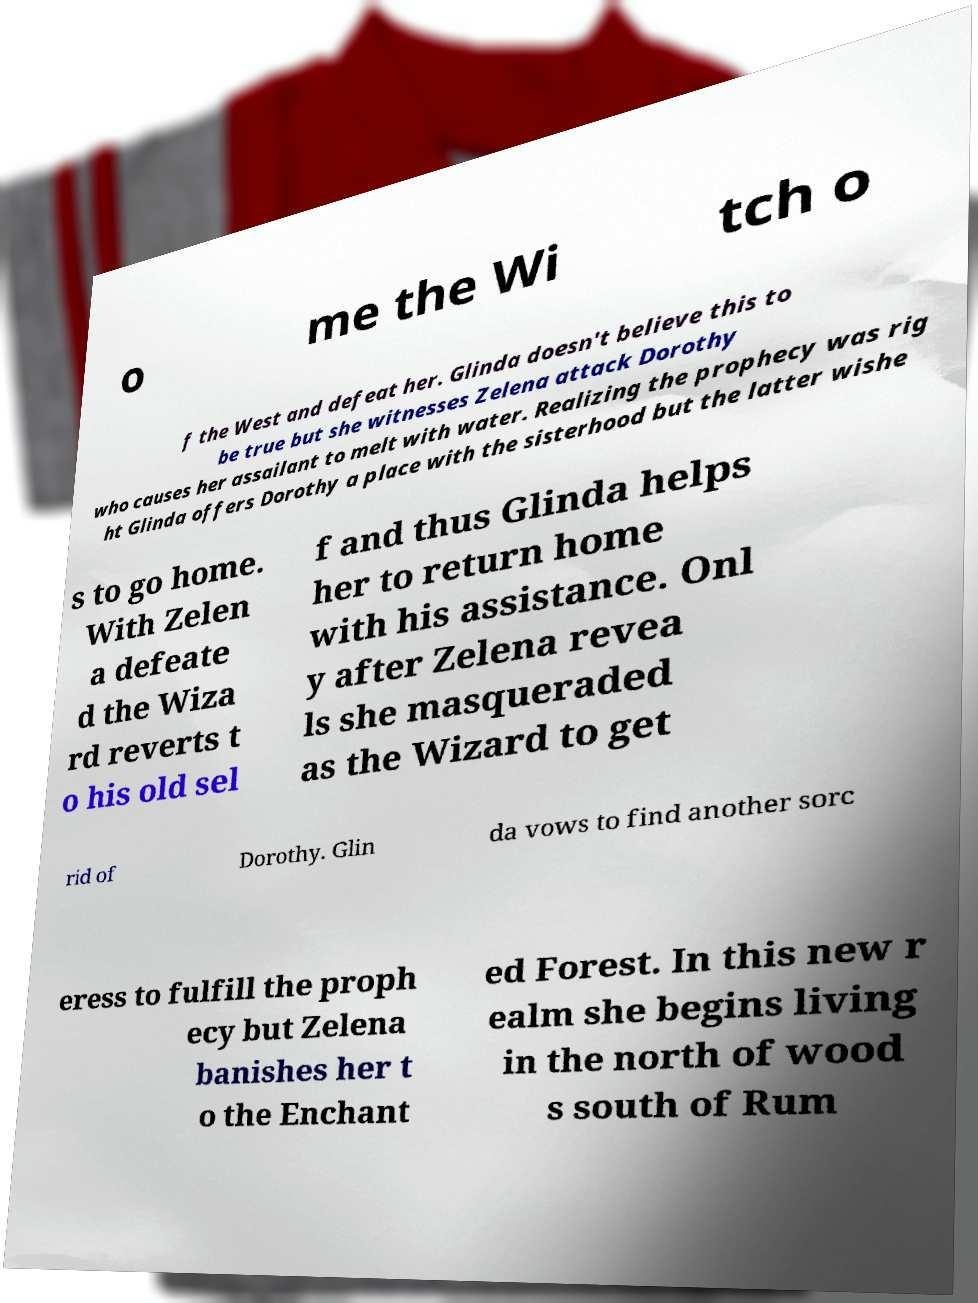Can you accurately transcribe the text from the provided image for me? o me the Wi tch o f the West and defeat her. Glinda doesn't believe this to be true but she witnesses Zelena attack Dorothy who causes her assailant to melt with water. Realizing the prophecy was rig ht Glinda offers Dorothy a place with the sisterhood but the latter wishe s to go home. With Zelen a defeate d the Wiza rd reverts t o his old sel f and thus Glinda helps her to return home with his assistance. Onl y after Zelena revea ls she masqueraded as the Wizard to get rid of Dorothy. Glin da vows to find another sorc eress to fulfill the proph ecy but Zelena banishes her t o the Enchant ed Forest. In this new r ealm she begins living in the north of wood s south of Rum 